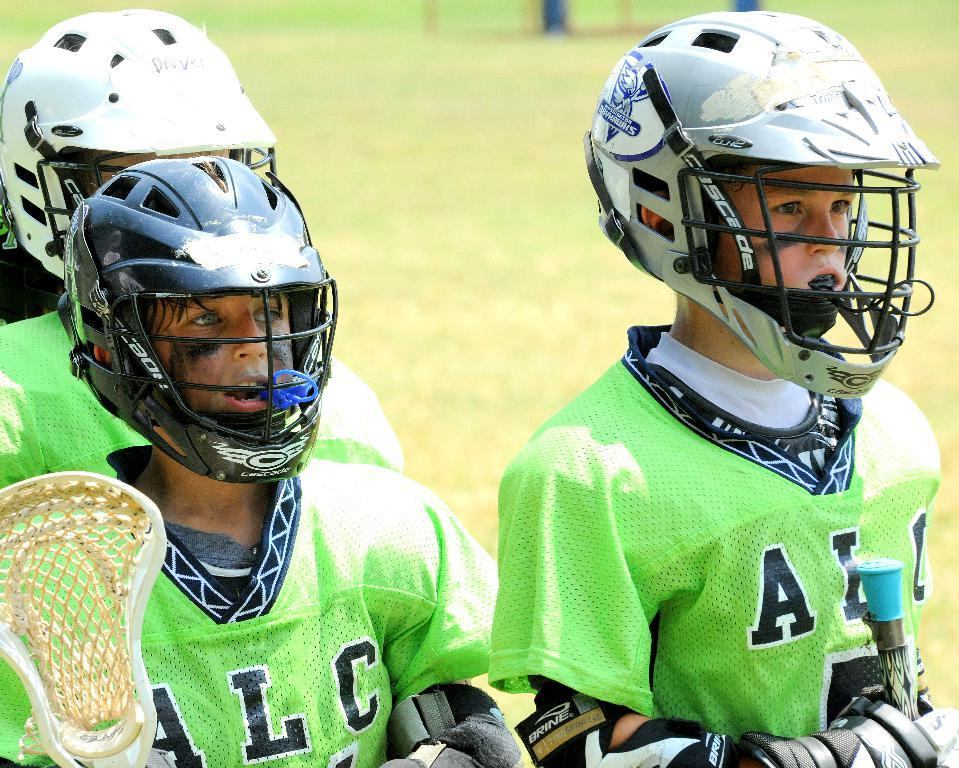How many people are in the image? There are three persons in the image. What colors are the dresses of the persons in the image? The persons are wearing green and white color dresses. What protective gear are the persons wearing in the image? The persons are wearing helmets. What is the color of the background in the image? The background of the image is green. What language are the persons speaking in the image? The image does not provide any information about the language being spoken by the persons. How many planes can be seen in the image? There are no planes visible in the image. 